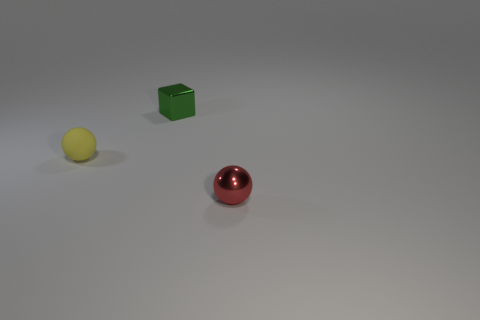Add 1 tiny yellow matte balls. How many objects exist? 4 Subtract all spheres. How many objects are left? 1 Subtract all tiny yellow balls. Subtract all big yellow matte spheres. How many objects are left? 2 Add 3 small red objects. How many small red objects are left? 4 Add 3 yellow spheres. How many yellow spheres exist? 4 Subtract 0 yellow cylinders. How many objects are left? 3 